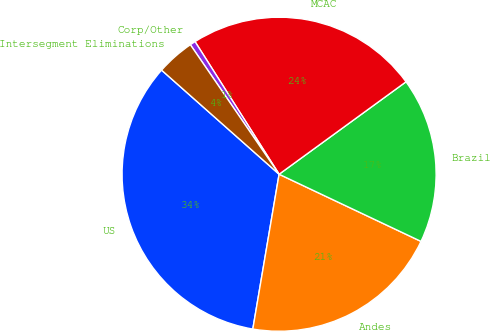Convert chart. <chart><loc_0><loc_0><loc_500><loc_500><pie_chart><fcel>US<fcel>Andes<fcel>Brazil<fcel>MCAC<fcel>Corp/Other<fcel>Intersegment Eliminations<nl><fcel>33.86%<fcel>20.64%<fcel>17.05%<fcel>23.97%<fcel>0.57%<fcel>3.9%<nl></chart> 